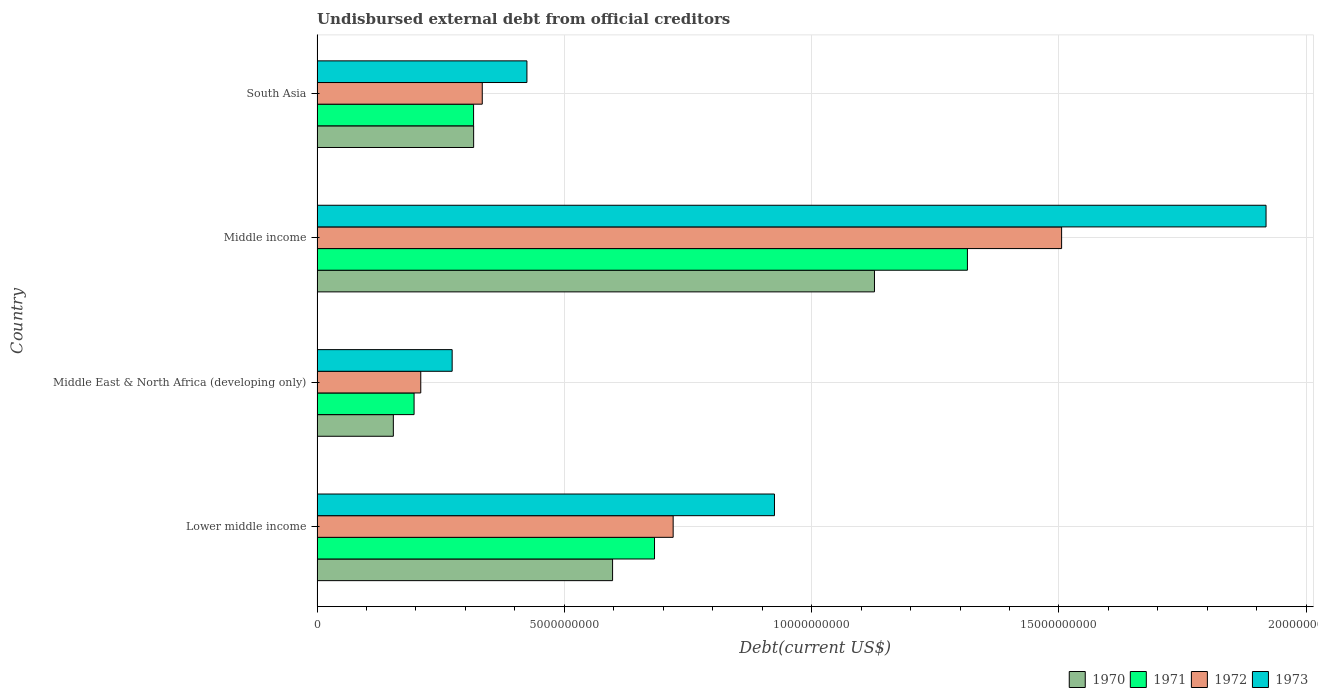How many different coloured bars are there?
Offer a terse response. 4. Are the number of bars on each tick of the Y-axis equal?
Give a very brief answer. Yes. How many bars are there on the 1st tick from the top?
Your response must be concise. 4. In how many cases, is the number of bars for a given country not equal to the number of legend labels?
Offer a very short reply. 0. What is the total debt in 1973 in Lower middle income?
Your answer should be compact. 9.25e+09. Across all countries, what is the maximum total debt in 1972?
Provide a short and direct response. 1.51e+1. Across all countries, what is the minimum total debt in 1971?
Your answer should be very brief. 1.96e+09. In which country was the total debt in 1970 minimum?
Ensure brevity in your answer.  Middle East & North Africa (developing only). What is the total total debt in 1970 in the graph?
Offer a very short reply. 2.20e+1. What is the difference between the total debt in 1973 in Lower middle income and that in Middle income?
Your answer should be compact. -9.94e+09. What is the difference between the total debt in 1971 in South Asia and the total debt in 1970 in Middle income?
Keep it short and to the point. -8.11e+09. What is the average total debt in 1973 per country?
Ensure brevity in your answer.  8.85e+09. What is the difference between the total debt in 1973 and total debt in 1971 in Middle income?
Offer a very short reply. 6.04e+09. In how many countries, is the total debt in 1973 greater than 15000000000 US$?
Give a very brief answer. 1. What is the ratio of the total debt in 1972 in Middle East & North Africa (developing only) to that in Middle income?
Offer a terse response. 0.14. Is the total debt in 1973 in Lower middle income less than that in Middle income?
Keep it short and to the point. Yes. Is the difference between the total debt in 1973 in Middle East & North Africa (developing only) and Middle income greater than the difference between the total debt in 1971 in Middle East & North Africa (developing only) and Middle income?
Your response must be concise. No. What is the difference between the highest and the second highest total debt in 1970?
Your answer should be very brief. 5.30e+09. What is the difference between the highest and the lowest total debt in 1973?
Your answer should be very brief. 1.65e+1. In how many countries, is the total debt in 1972 greater than the average total debt in 1972 taken over all countries?
Your answer should be compact. 2. What does the 1st bar from the bottom in Lower middle income represents?
Offer a terse response. 1970. Is it the case that in every country, the sum of the total debt in 1970 and total debt in 1971 is greater than the total debt in 1973?
Give a very brief answer. Yes. How many countries are there in the graph?
Ensure brevity in your answer.  4. What is the difference between two consecutive major ticks on the X-axis?
Offer a terse response. 5.00e+09. Does the graph contain any zero values?
Provide a short and direct response. No. Does the graph contain grids?
Keep it short and to the point. Yes. How many legend labels are there?
Make the answer very short. 4. How are the legend labels stacked?
Your answer should be compact. Horizontal. What is the title of the graph?
Your answer should be compact. Undisbursed external debt from official creditors. What is the label or title of the X-axis?
Provide a succinct answer. Debt(current US$). What is the Debt(current US$) of 1970 in Lower middle income?
Your response must be concise. 5.98e+09. What is the Debt(current US$) in 1971 in Lower middle income?
Give a very brief answer. 6.82e+09. What is the Debt(current US$) in 1972 in Lower middle income?
Give a very brief answer. 7.20e+09. What is the Debt(current US$) of 1973 in Lower middle income?
Your response must be concise. 9.25e+09. What is the Debt(current US$) of 1970 in Middle East & North Africa (developing only)?
Make the answer very short. 1.54e+09. What is the Debt(current US$) of 1971 in Middle East & North Africa (developing only)?
Your response must be concise. 1.96e+09. What is the Debt(current US$) of 1972 in Middle East & North Africa (developing only)?
Make the answer very short. 2.10e+09. What is the Debt(current US$) in 1973 in Middle East & North Africa (developing only)?
Your answer should be very brief. 2.73e+09. What is the Debt(current US$) of 1970 in Middle income?
Provide a short and direct response. 1.13e+1. What is the Debt(current US$) in 1971 in Middle income?
Your answer should be compact. 1.32e+1. What is the Debt(current US$) in 1972 in Middle income?
Ensure brevity in your answer.  1.51e+1. What is the Debt(current US$) in 1973 in Middle income?
Your answer should be very brief. 1.92e+1. What is the Debt(current US$) in 1970 in South Asia?
Your answer should be compact. 3.17e+09. What is the Debt(current US$) of 1971 in South Asia?
Your response must be concise. 3.16e+09. What is the Debt(current US$) in 1972 in South Asia?
Give a very brief answer. 3.34e+09. What is the Debt(current US$) of 1973 in South Asia?
Give a very brief answer. 4.24e+09. Across all countries, what is the maximum Debt(current US$) in 1970?
Your answer should be compact. 1.13e+1. Across all countries, what is the maximum Debt(current US$) in 1971?
Provide a succinct answer. 1.32e+1. Across all countries, what is the maximum Debt(current US$) of 1972?
Offer a very short reply. 1.51e+1. Across all countries, what is the maximum Debt(current US$) in 1973?
Give a very brief answer. 1.92e+1. Across all countries, what is the minimum Debt(current US$) in 1970?
Your response must be concise. 1.54e+09. Across all countries, what is the minimum Debt(current US$) of 1971?
Your answer should be compact. 1.96e+09. Across all countries, what is the minimum Debt(current US$) in 1972?
Provide a succinct answer. 2.10e+09. Across all countries, what is the minimum Debt(current US$) of 1973?
Your answer should be compact. 2.73e+09. What is the total Debt(current US$) of 1970 in the graph?
Your answer should be compact. 2.20e+1. What is the total Debt(current US$) in 1971 in the graph?
Your answer should be very brief. 2.51e+1. What is the total Debt(current US$) of 1972 in the graph?
Your answer should be compact. 2.77e+1. What is the total Debt(current US$) in 1973 in the graph?
Make the answer very short. 3.54e+1. What is the difference between the Debt(current US$) in 1970 in Lower middle income and that in Middle East & North Africa (developing only)?
Your response must be concise. 4.43e+09. What is the difference between the Debt(current US$) in 1971 in Lower middle income and that in Middle East & North Africa (developing only)?
Ensure brevity in your answer.  4.86e+09. What is the difference between the Debt(current US$) in 1972 in Lower middle income and that in Middle East & North Africa (developing only)?
Keep it short and to the point. 5.10e+09. What is the difference between the Debt(current US$) in 1973 in Lower middle income and that in Middle East & North Africa (developing only)?
Keep it short and to the point. 6.52e+09. What is the difference between the Debt(current US$) of 1970 in Lower middle income and that in Middle income?
Give a very brief answer. -5.30e+09. What is the difference between the Debt(current US$) of 1971 in Lower middle income and that in Middle income?
Make the answer very short. -6.33e+09. What is the difference between the Debt(current US$) in 1972 in Lower middle income and that in Middle income?
Provide a succinct answer. -7.85e+09. What is the difference between the Debt(current US$) of 1973 in Lower middle income and that in Middle income?
Offer a terse response. -9.94e+09. What is the difference between the Debt(current US$) of 1970 in Lower middle income and that in South Asia?
Your answer should be compact. 2.81e+09. What is the difference between the Debt(current US$) in 1971 in Lower middle income and that in South Asia?
Make the answer very short. 3.66e+09. What is the difference between the Debt(current US$) of 1972 in Lower middle income and that in South Asia?
Your answer should be compact. 3.86e+09. What is the difference between the Debt(current US$) of 1973 in Lower middle income and that in South Asia?
Keep it short and to the point. 5.01e+09. What is the difference between the Debt(current US$) of 1970 in Middle East & North Africa (developing only) and that in Middle income?
Your answer should be very brief. -9.73e+09. What is the difference between the Debt(current US$) of 1971 in Middle East & North Africa (developing only) and that in Middle income?
Your response must be concise. -1.12e+1. What is the difference between the Debt(current US$) in 1972 in Middle East & North Africa (developing only) and that in Middle income?
Offer a terse response. -1.30e+1. What is the difference between the Debt(current US$) of 1973 in Middle East & North Africa (developing only) and that in Middle income?
Offer a terse response. -1.65e+1. What is the difference between the Debt(current US$) of 1970 in Middle East & North Africa (developing only) and that in South Asia?
Offer a very short reply. -1.62e+09. What is the difference between the Debt(current US$) in 1971 in Middle East & North Africa (developing only) and that in South Asia?
Your answer should be very brief. -1.20e+09. What is the difference between the Debt(current US$) in 1972 in Middle East & North Africa (developing only) and that in South Asia?
Ensure brevity in your answer.  -1.24e+09. What is the difference between the Debt(current US$) in 1973 in Middle East & North Africa (developing only) and that in South Asia?
Offer a very short reply. -1.51e+09. What is the difference between the Debt(current US$) in 1970 in Middle income and that in South Asia?
Your response must be concise. 8.10e+09. What is the difference between the Debt(current US$) in 1971 in Middle income and that in South Asia?
Offer a very short reply. 9.99e+09. What is the difference between the Debt(current US$) in 1972 in Middle income and that in South Asia?
Offer a very short reply. 1.17e+1. What is the difference between the Debt(current US$) of 1973 in Middle income and that in South Asia?
Offer a very short reply. 1.49e+1. What is the difference between the Debt(current US$) of 1970 in Lower middle income and the Debt(current US$) of 1971 in Middle East & North Africa (developing only)?
Your answer should be compact. 4.01e+09. What is the difference between the Debt(current US$) in 1970 in Lower middle income and the Debt(current US$) in 1972 in Middle East & North Africa (developing only)?
Your response must be concise. 3.88e+09. What is the difference between the Debt(current US$) in 1970 in Lower middle income and the Debt(current US$) in 1973 in Middle East & North Africa (developing only)?
Your answer should be compact. 3.24e+09. What is the difference between the Debt(current US$) in 1971 in Lower middle income and the Debt(current US$) in 1972 in Middle East & North Africa (developing only)?
Your response must be concise. 4.73e+09. What is the difference between the Debt(current US$) of 1971 in Lower middle income and the Debt(current US$) of 1973 in Middle East & North Africa (developing only)?
Give a very brief answer. 4.09e+09. What is the difference between the Debt(current US$) of 1972 in Lower middle income and the Debt(current US$) of 1973 in Middle East & North Africa (developing only)?
Offer a terse response. 4.47e+09. What is the difference between the Debt(current US$) in 1970 in Lower middle income and the Debt(current US$) in 1971 in Middle income?
Give a very brief answer. -7.17e+09. What is the difference between the Debt(current US$) in 1970 in Lower middle income and the Debt(current US$) in 1972 in Middle income?
Offer a very short reply. -9.08e+09. What is the difference between the Debt(current US$) of 1970 in Lower middle income and the Debt(current US$) of 1973 in Middle income?
Your answer should be compact. -1.32e+1. What is the difference between the Debt(current US$) in 1971 in Lower middle income and the Debt(current US$) in 1972 in Middle income?
Your response must be concise. -8.23e+09. What is the difference between the Debt(current US$) of 1971 in Lower middle income and the Debt(current US$) of 1973 in Middle income?
Provide a succinct answer. -1.24e+1. What is the difference between the Debt(current US$) of 1972 in Lower middle income and the Debt(current US$) of 1973 in Middle income?
Keep it short and to the point. -1.20e+1. What is the difference between the Debt(current US$) of 1970 in Lower middle income and the Debt(current US$) of 1971 in South Asia?
Provide a succinct answer. 2.81e+09. What is the difference between the Debt(current US$) of 1970 in Lower middle income and the Debt(current US$) of 1972 in South Asia?
Provide a short and direct response. 2.63e+09. What is the difference between the Debt(current US$) of 1970 in Lower middle income and the Debt(current US$) of 1973 in South Asia?
Your answer should be very brief. 1.73e+09. What is the difference between the Debt(current US$) in 1971 in Lower middle income and the Debt(current US$) in 1972 in South Asia?
Give a very brief answer. 3.48e+09. What is the difference between the Debt(current US$) in 1971 in Lower middle income and the Debt(current US$) in 1973 in South Asia?
Provide a succinct answer. 2.58e+09. What is the difference between the Debt(current US$) in 1972 in Lower middle income and the Debt(current US$) in 1973 in South Asia?
Keep it short and to the point. 2.96e+09. What is the difference between the Debt(current US$) of 1970 in Middle East & North Africa (developing only) and the Debt(current US$) of 1971 in Middle income?
Provide a succinct answer. -1.16e+1. What is the difference between the Debt(current US$) in 1970 in Middle East & North Africa (developing only) and the Debt(current US$) in 1972 in Middle income?
Offer a terse response. -1.35e+1. What is the difference between the Debt(current US$) in 1970 in Middle East & North Africa (developing only) and the Debt(current US$) in 1973 in Middle income?
Offer a terse response. -1.76e+1. What is the difference between the Debt(current US$) of 1971 in Middle East & North Africa (developing only) and the Debt(current US$) of 1972 in Middle income?
Ensure brevity in your answer.  -1.31e+1. What is the difference between the Debt(current US$) in 1971 in Middle East & North Africa (developing only) and the Debt(current US$) in 1973 in Middle income?
Your answer should be very brief. -1.72e+1. What is the difference between the Debt(current US$) of 1972 in Middle East & North Africa (developing only) and the Debt(current US$) of 1973 in Middle income?
Provide a short and direct response. -1.71e+1. What is the difference between the Debt(current US$) of 1970 in Middle East & North Africa (developing only) and the Debt(current US$) of 1971 in South Asia?
Offer a terse response. -1.62e+09. What is the difference between the Debt(current US$) of 1970 in Middle East & North Africa (developing only) and the Debt(current US$) of 1972 in South Asia?
Give a very brief answer. -1.80e+09. What is the difference between the Debt(current US$) of 1970 in Middle East & North Africa (developing only) and the Debt(current US$) of 1973 in South Asia?
Give a very brief answer. -2.70e+09. What is the difference between the Debt(current US$) of 1971 in Middle East & North Africa (developing only) and the Debt(current US$) of 1972 in South Asia?
Ensure brevity in your answer.  -1.38e+09. What is the difference between the Debt(current US$) of 1971 in Middle East & North Africa (developing only) and the Debt(current US$) of 1973 in South Asia?
Ensure brevity in your answer.  -2.28e+09. What is the difference between the Debt(current US$) in 1972 in Middle East & North Africa (developing only) and the Debt(current US$) in 1973 in South Asia?
Ensure brevity in your answer.  -2.15e+09. What is the difference between the Debt(current US$) in 1970 in Middle income and the Debt(current US$) in 1971 in South Asia?
Your response must be concise. 8.11e+09. What is the difference between the Debt(current US$) of 1970 in Middle income and the Debt(current US$) of 1972 in South Asia?
Provide a short and direct response. 7.93e+09. What is the difference between the Debt(current US$) in 1970 in Middle income and the Debt(current US$) in 1973 in South Asia?
Give a very brief answer. 7.03e+09. What is the difference between the Debt(current US$) in 1971 in Middle income and the Debt(current US$) in 1972 in South Asia?
Make the answer very short. 9.81e+09. What is the difference between the Debt(current US$) of 1971 in Middle income and the Debt(current US$) of 1973 in South Asia?
Your answer should be compact. 8.91e+09. What is the difference between the Debt(current US$) in 1972 in Middle income and the Debt(current US$) in 1973 in South Asia?
Provide a short and direct response. 1.08e+1. What is the average Debt(current US$) of 1970 per country?
Your answer should be compact. 5.49e+09. What is the average Debt(current US$) of 1971 per country?
Offer a very short reply. 6.28e+09. What is the average Debt(current US$) in 1972 per country?
Make the answer very short. 6.92e+09. What is the average Debt(current US$) in 1973 per country?
Your answer should be compact. 8.85e+09. What is the difference between the Debt(current US$) of 1970 and Debt(current US$) of 1971 in Lower middle income?
Keep it short and to the point. -8.48e+08. What is the difference between the Debt(current US$) in 1970 and Debt(current US$) in 1972 in Lower middle income?
Ensure brevity in your answer.  -1.22e+09. What is the difference between the Debt(current US$) of 1970 and Debt(current US$) of 1973 in Lower middle income?
Your response must be concise. -3.27e+09. What is the difference between the Debt(current US$) of 1971 and Debt(current US$) of 1972 in Lower middle income?
Keep it short and to the point. -3.77e+08. What is the difference between the Debt(current US$) in 1971 and Debt(current US$) in 1973 in Lower middle income?
Keep it short and to the point. -2.43e+09. What is the difference between the Debt(current US$) of 1972 and Debt(current US$) of 1973 in Lower middle income?
Ensure brevity in your answer.  -2.05e+09. What is the difference between the Debt(current US$) in 1970 and Debt(current US$) in 1971 in Middle East & North Africa (developing only)?
Ensure brevity in your answer.  -4.19e+08. What is the difference between the Debt(current US$) of 1970 and Debt(current US$) of 1972 in Middle East & North Africa (developing only)?
Provide a succinct answer. -5.55e+08. What is the difference between the Debt(current US$) in 1970 and Debt(current US$) in 1973 in Middle East & North Africa (developing only)?
Provide a short and direct response. -1.19e+09. What is the difference between the Debt(current US$) of 1971 and Debt(current US$) of 1972 in Middle East & North Africa (developing only)?
Your answer should be very brief. -1.35e+08. What is the difference between the Debt(current US$) of 1971 and Debt(current US$) of 1973 in Middle East & North Africa (developing only)?
Provide a short and direct response. -7.70e+08. What is the difference between the Debt(current US$) of 1972 and Debt(current US$) of 1973 in Middle East & North Africa (developing only)?
Offer a terse response. -6.34e+08. What is the difference between the Debt(current US$) in 1970 and Debt(current US$) in 1971 in Middle income?
Offer a very short reply. -1.88e+09. What is the difference between the Debt(current US$) in 1970 and Debt(current US$) in 1972 in Middle income?
Ensure brevity in your answer.  -3.78e+09. What is the difference between the Debt(current US$) of 1970 and Debt(current US$) of 1973 in Middle income?
Provide a short and direct response. -7.92e+09. What is the difference between the Debt(current US$) in 1971 and Debt(current US$) in 1972 in Middle income?
Offer a terse response. -1.90e+09. What is the difference between the Debt(current US$) in 1971 and Debt(current US$) in 1973 in Middle income?
Give a very brief answer. -6.04e+09. What is the difference between the Debt(current US$) of 1972 and Debt(current US$) of 1973 in Middle income?
Provide a succinct answer. -4.13e+09. What is the difference between the Debt(current US$) in 1970 and Debt(current US$) in 1971 in South Asia?
Your response must be concise. 1.31e+06. What is the difference between the Debt(current US$) of 1970 and Debt(current US$) of 1972 in South Asia?
Your answer should be compact. -1.74e+08. What is the difference between the Debt(current US$) of 1970 and Debt(current US$) of 1973 in South Asia?
Keep it short and to the point. -1.08e+09. What is the difference between the Debt(current US$) of 1971 and Debt(current US$) of 1972 in South Asia?
Offer a very short reply. -1.76e+08. What is the difference between the Debt(current US$) of 1971 and Debt(current US$) of 1973 in South Asia?
Provide a succinct answer. -1.08e+09. What is the difference between the Debt(current US$) of 1972 and Debt(current US$) of 1973 in South Asia?
Your answer should be compact. -9.03e+08. What is the ratio of the Debt(current US$) in 1970 in Lower middle income to that in Middle East & North Africa (developing only)?
Make the answer very short. 3.87. What is the ratio of the Debt(current US$) of 1971 in Lower middle income to that in Middle East & North Africa (developing only)?
Ensure brevity in your answer.  3.48. What is the ratio of the Debt(current US$) in 1972 in Lower middle income to that in Middle East & North Africa (developing only)?
Provide a succinct answer. 3.43. What is the ratio of the Debt(current US$) in 1973 in Lower middle income to that in Middle East & North Africa (developing only)?
Your answer should be compact. 3.39. What is the ratio of the Debt(current US$) of 1970 in Lower middle income to that in Middle income?
Offer a very short reply. 0.53. What is the ratio of the Debt(current US$) of 1971 in Lower middle income to that in Middle income?
Provide a succinct answer. 0.52. What is the ratio of the Debt(current US$) in 1972 in Lower middle income to that in Middle income?
Offer a terse response. 0.48. What is the ratio of the Debt(current US$) in 1973 in Lower middle income to that in Middle income?
Your answer should be compact. 0.48. What is the ratio of the Debt(current US$) in 1970 in Lower middle income to that in South Asia?
Your answer should be very brief. 1.89. What is the ratio of the Debt(current US$) in 1971 in Lower middle income to that in South Asia?
Make the answer very short. 2.16. What is the ratio of the Debt(current US$) of 1972 in Lower middle income to that in South Asia?
Offer a very short reply. 2.16. What is the ratio of the Debt(current US$) of 1973 in Lower middle income to that in South Asia?
Make the answer very short. 2.18. What is the ratio of the Debt(current US$) in 1970 in Middle East & North Africa (developing only) to that in Middle income?
Provide a succinct answer. 0.14. What is the ratio of the Debt(current US$) in 1971 in Middle East & North Africa (developing only) to that in Middle income?
Give a very brief answer. 0.15. What is the ratio of the Debt(current US$) in 1972 in Middle East & North Africa (developing only) to that in Middle income?
Offer a terse response. 0.14. What is the ratio of the Debt(current US$) of 1973 in Middle East & North Africa (developing only) to that in Middle income?
Your response must be concise. 0.14. What is the ratio of the Debt(current US$) of 1970 in Middle East & North Africa (developing only) to that in South Asia?
Offer a terse response. 0.49. What is the ratio of the Debt(current US$) in 1971 in Middle East & North Africa (developing only) to that in South Asia?
Make the answer very short. 0.62. What is the ratio of the Debt(current US$) in 1972 in Middle East & North Africa (developing only) to that in South Asia?
Provide a short and direct response. 0.63. What is the ratio of the Debt(current US$) in 1973 in Middle East & North Africa (developing only) to that in South Asia?
Provide a succinct answer. 0.64. What is the ratio of the Debt(current US$) of 1970 in Middle income to that in South Asia?
Provide a succinct answer. 3.56. What is the ratio of the Debt(current US$) in 1971 in Middle income to that in South Asia?
Offer a terse response. 4.16. What is the ratio of the Debt(current US$) of 1972 in Middle income to that in South Asia?
Provide a succinct answer. 4.51. What is the ratio of the Debt(current US$) of 1973 in Middle income to that in South Asia?
Keep it short and to the point. 4.52. What is the difference between the highest and the second highest Debt(current US$) in 1970?
Keep it short and to the point. 5.30e+09. What is the difference between the highest and the second highest Debt(current US$) in 1971?
Provide a succinct answer. 6.33e+09. What is the difference between the highest and the second highest Debt(current US$) in 1972?
Your answer should be compact. 7.85e+09. What is the difference between the highest and the second highest Debt(current US$) in 1973?
Offer a very short reply. 9.94e+09. What is the difference between the highest and the lowest Debt(current US$) of 1970?
Provide a succinct answer. 9.73e+09. What is the difference between the highest and the lowest Debt(current US$) of 1971?
Your answer should be compact. 1.12e+1. What is the difference between the highest and the lowest Debt(current US$) of 1972?
Your response must be concise. 1.30e+1. What is the difference between the highest and the lowest Debt(current US$) in 1973?
Your response must be concise. 1.65e+1. 